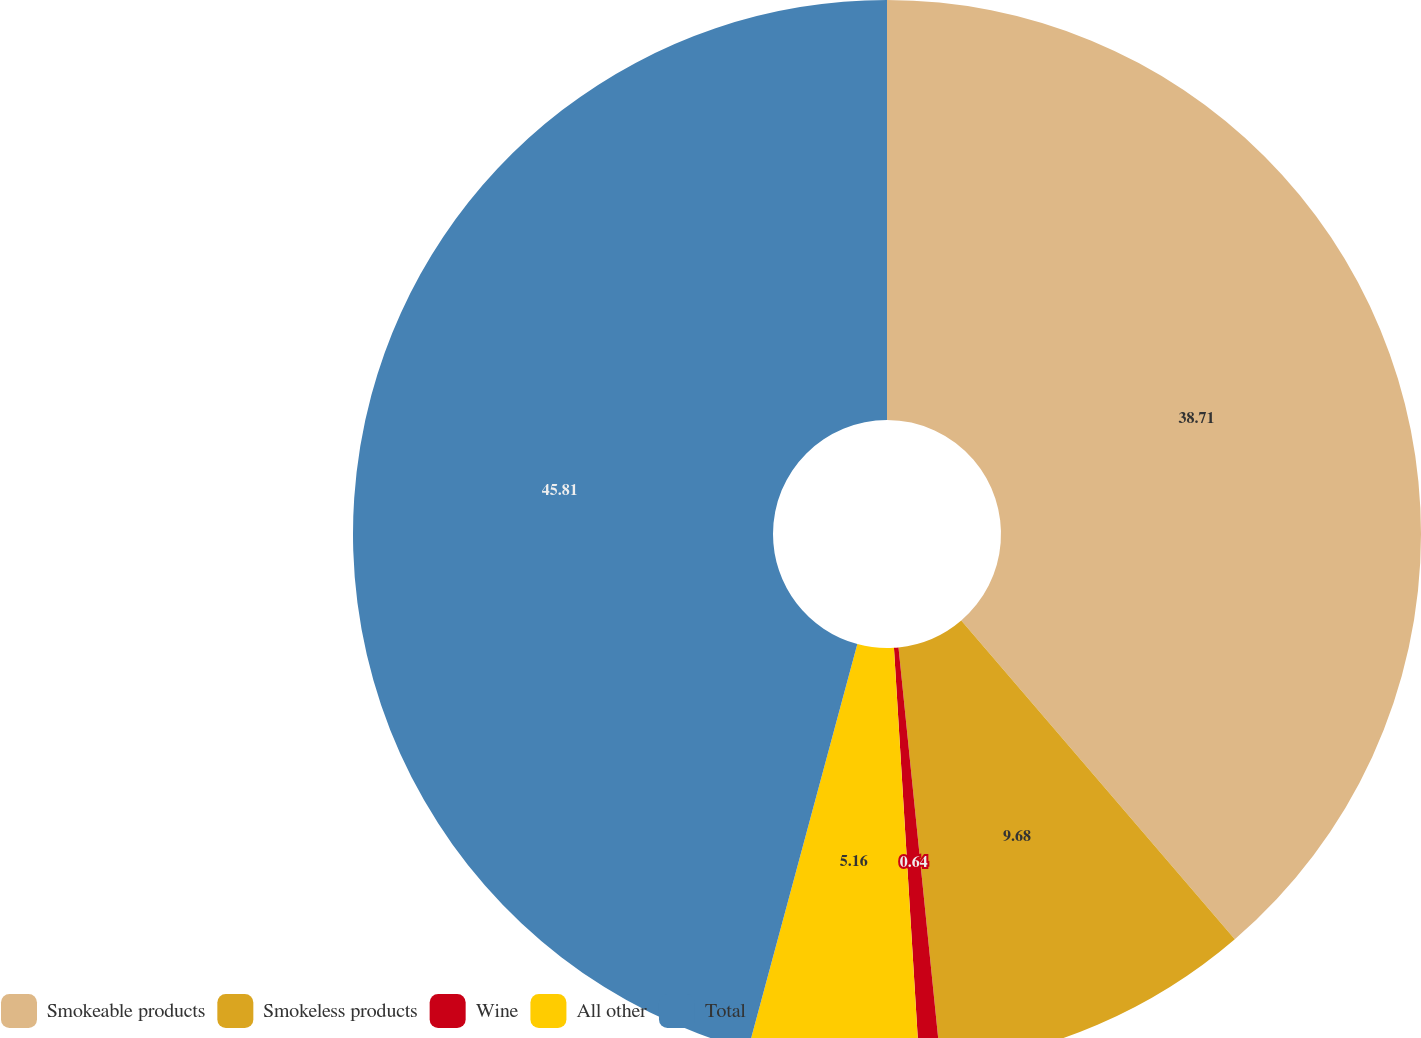<chart> <loc_0><loc_0><loc_500><loc_500><pie_chart><fcel>Smokeable products<fcel>Smokeless products<fcel>Wine<fcel>All other<fcel>Total<nl><fcel>38.71%<fcel>9.68%<fcel>0.64%<fcel>5.16%<fcel>45.81%<nl></chart> 